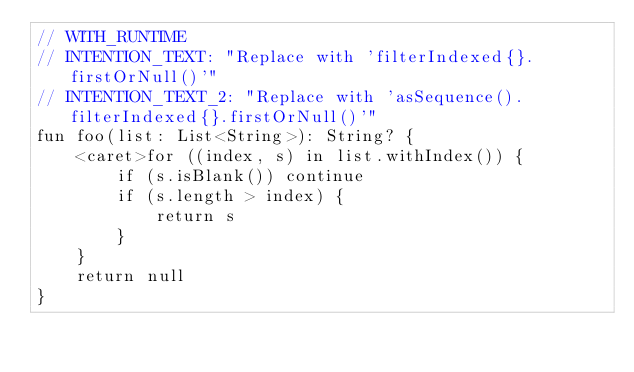<code> <loc_0><loc_0><loc_500><loc_500><_Kotlin_>// WITH_RUNTIME
// INTENTION_TEXT: "Replace with 'filterIndexed{}.firstOrNull()'"
// INTENTION_TEXT_2: "Replace with 'asSequence().filterIndexed{}.firstOrNull()'"
fun foo(list: List<String>): String? {
    <caret>for ((index, s) in list.withIndex()) {
        if (s.isBlank()) continue
        if (s.length > index) {
            return s
        }
    }
    return null
}</code> 